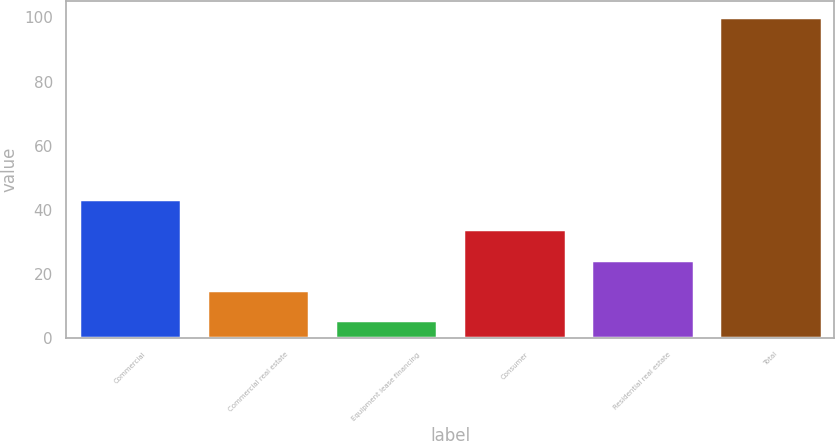Convert chart. <chart><loc_0><loc_0><loc_500><loc_500><bar_chart><fcel>Commercial<fcel>Commercial real estate<fcel>Equipment lease financing<fcel>Consumer<fcel>Residential real estate<fcel>Total<nl><fcel>43.36<fcel>15.04<fcel>5.6<fcel>33.92<fcel>24.48<fcel>100<nl></chart> 